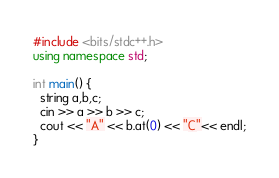Convert code to text. <code><loc_0><loc_0><loc_500><loc_500><_C++_>#include <bits/stdc++.h>
using namespace std;
 
int main() {
  string a,b,c;
  cin >> a >> b >> c;
  cout << "A" << b.at(0) << "C"<< endl;
}</code> 